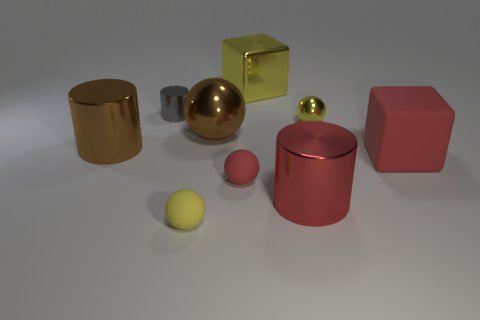There is a ball that is the same size as the yellow cube; what material is it?
Provide a succinct answer. Metal. Is the number of yellow objects on the left side of the small yellow metal object greater than the number of large red metallic objects left of the shiny block?
Ensure brevity in your answer.  Yes. Is there a gray metal object of the same shape as the big red matte thing?
Your response must be concise. No. What is the shape of the matte thing that is the same size as the red metal cylinder?
Make the answer very short. Cube. What is the shape of the large brown object left of the big brown metal ball?
Ensure brevity in your answer.  Cylinder. Are there fewer brown metal balls that are in front of the matte block than large cylinders to the left of the red shiny object?
Your answer should be very brief. Yes. There is a red metallic cylinder; does it have the same size as the yellow metal thing behind the gray object?
Offer a very short reply. Yes. What number of brown objects have the same size as the red matte block?
Give a very brief answer. 2. What color is the other small sphere that is the same material as the brown sphere?
Ensure brevity in your answer.  Yellow. Is the number of rubber objects greater than the number of yellow rubber blocks?
Offer a terse response. Yes. 